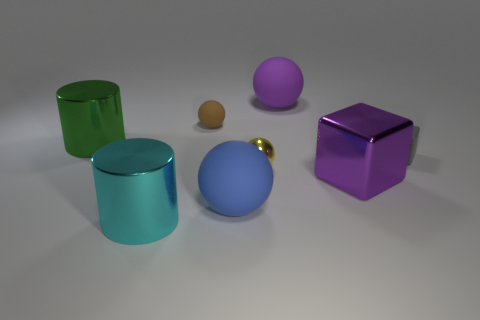What number of small yellow metal things are right of the brown rubber sphere?
Ensure brevity in your answer.  1. There is a big thing that is on the left side of the cylinder in front of the green object; what shape is it?
Your response must be concise. Cylinder. There is a large purple thing that is made of the same material as the tiny brown sphere; what is its shape?
Your answer should be very brief. Sphere. Does the rubber sphere that is in front of the brown rubber thing have the same size as the cylinder that is in front of the matte cube?
Your response must be concise. Yes. The big purple thing that is behind the yellow metallic object has what shape?
Offer a very short reply. Sphere. The big metal cube has what color?
Provide a succinct answer. Purple. There is a gray thing; is its size the same as the cylinder that is behind the small yellow shiny thing?
Keep it short and to the point. No. What number of metal objects are either tiny gray blocks or large cyan objects?
Offer a very short reply. 1. There is a shiny block; is its color the same as the big rubber thing that is right of the tiny yellow metal ball?
Provide a short and direct response. Yes. What shape is the purple metal thing?
Make the answer very short. Cube. 